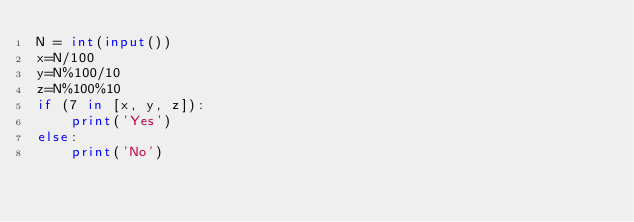<code> <loc_0><loc_0><loc_500><loc_500><_Python_>N = int(input())
x=N/100
y=N%100/10
z=N%100%10
if (7 in [x, y, z]):
    print('Yes')
else:
    print('No')</code> 